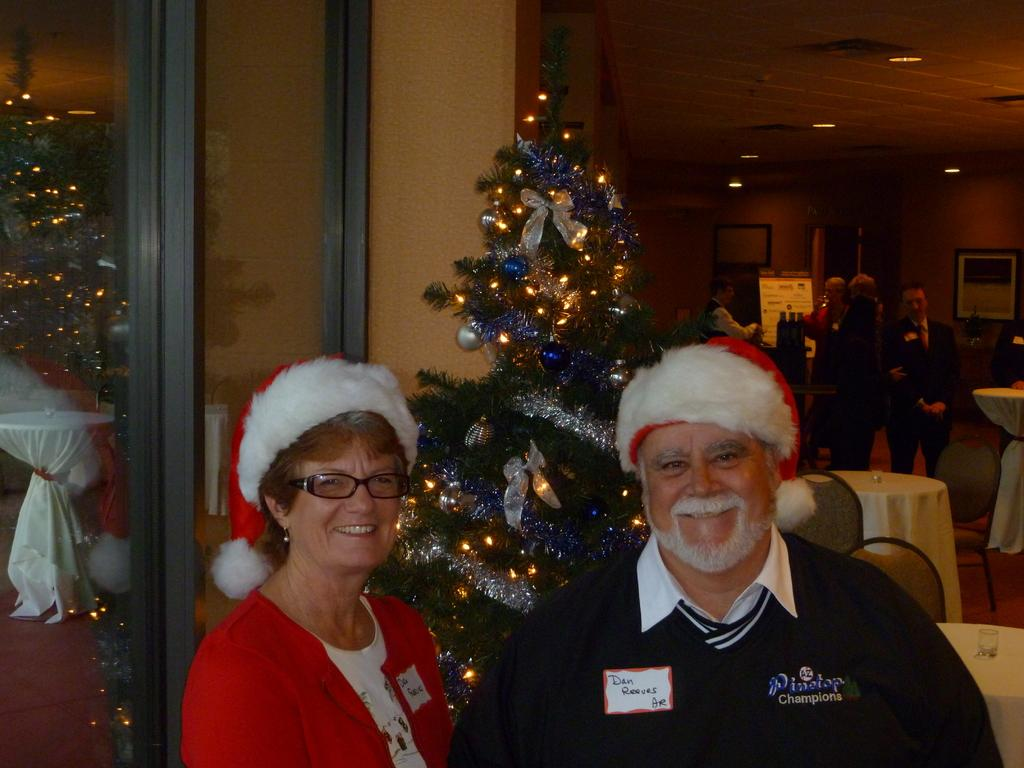<image>
Render a clear and concise summary of the photo. A guy named Dan is wearing a Santa hat while standing next to a woman. 